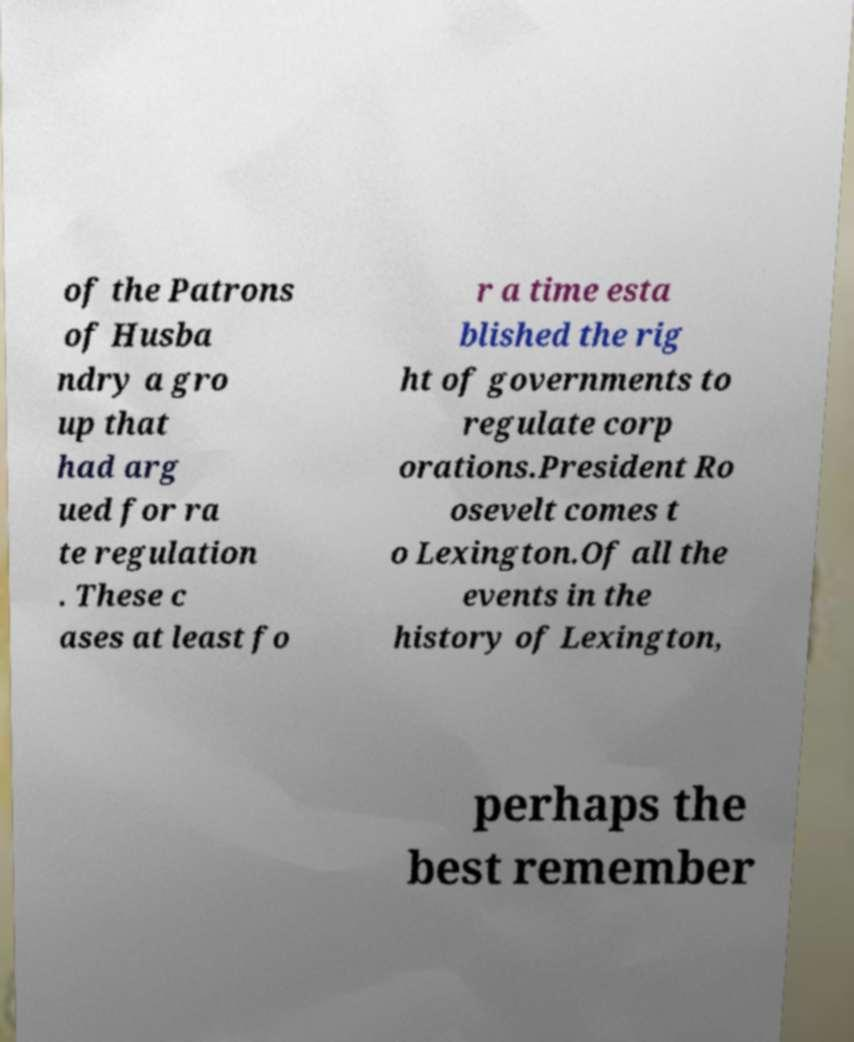Can you accurately transcribe the text from the provided image for me? of the Patrons of Husba ndry a gro up that had arg ued for ra te regulation . These c ases at least fo r a time esta blished the rig ht of governments to regulate corp orations.President Ro osevelt comes t o Lexington.Of all the events in the history of Lexington, perhaps the best remember 